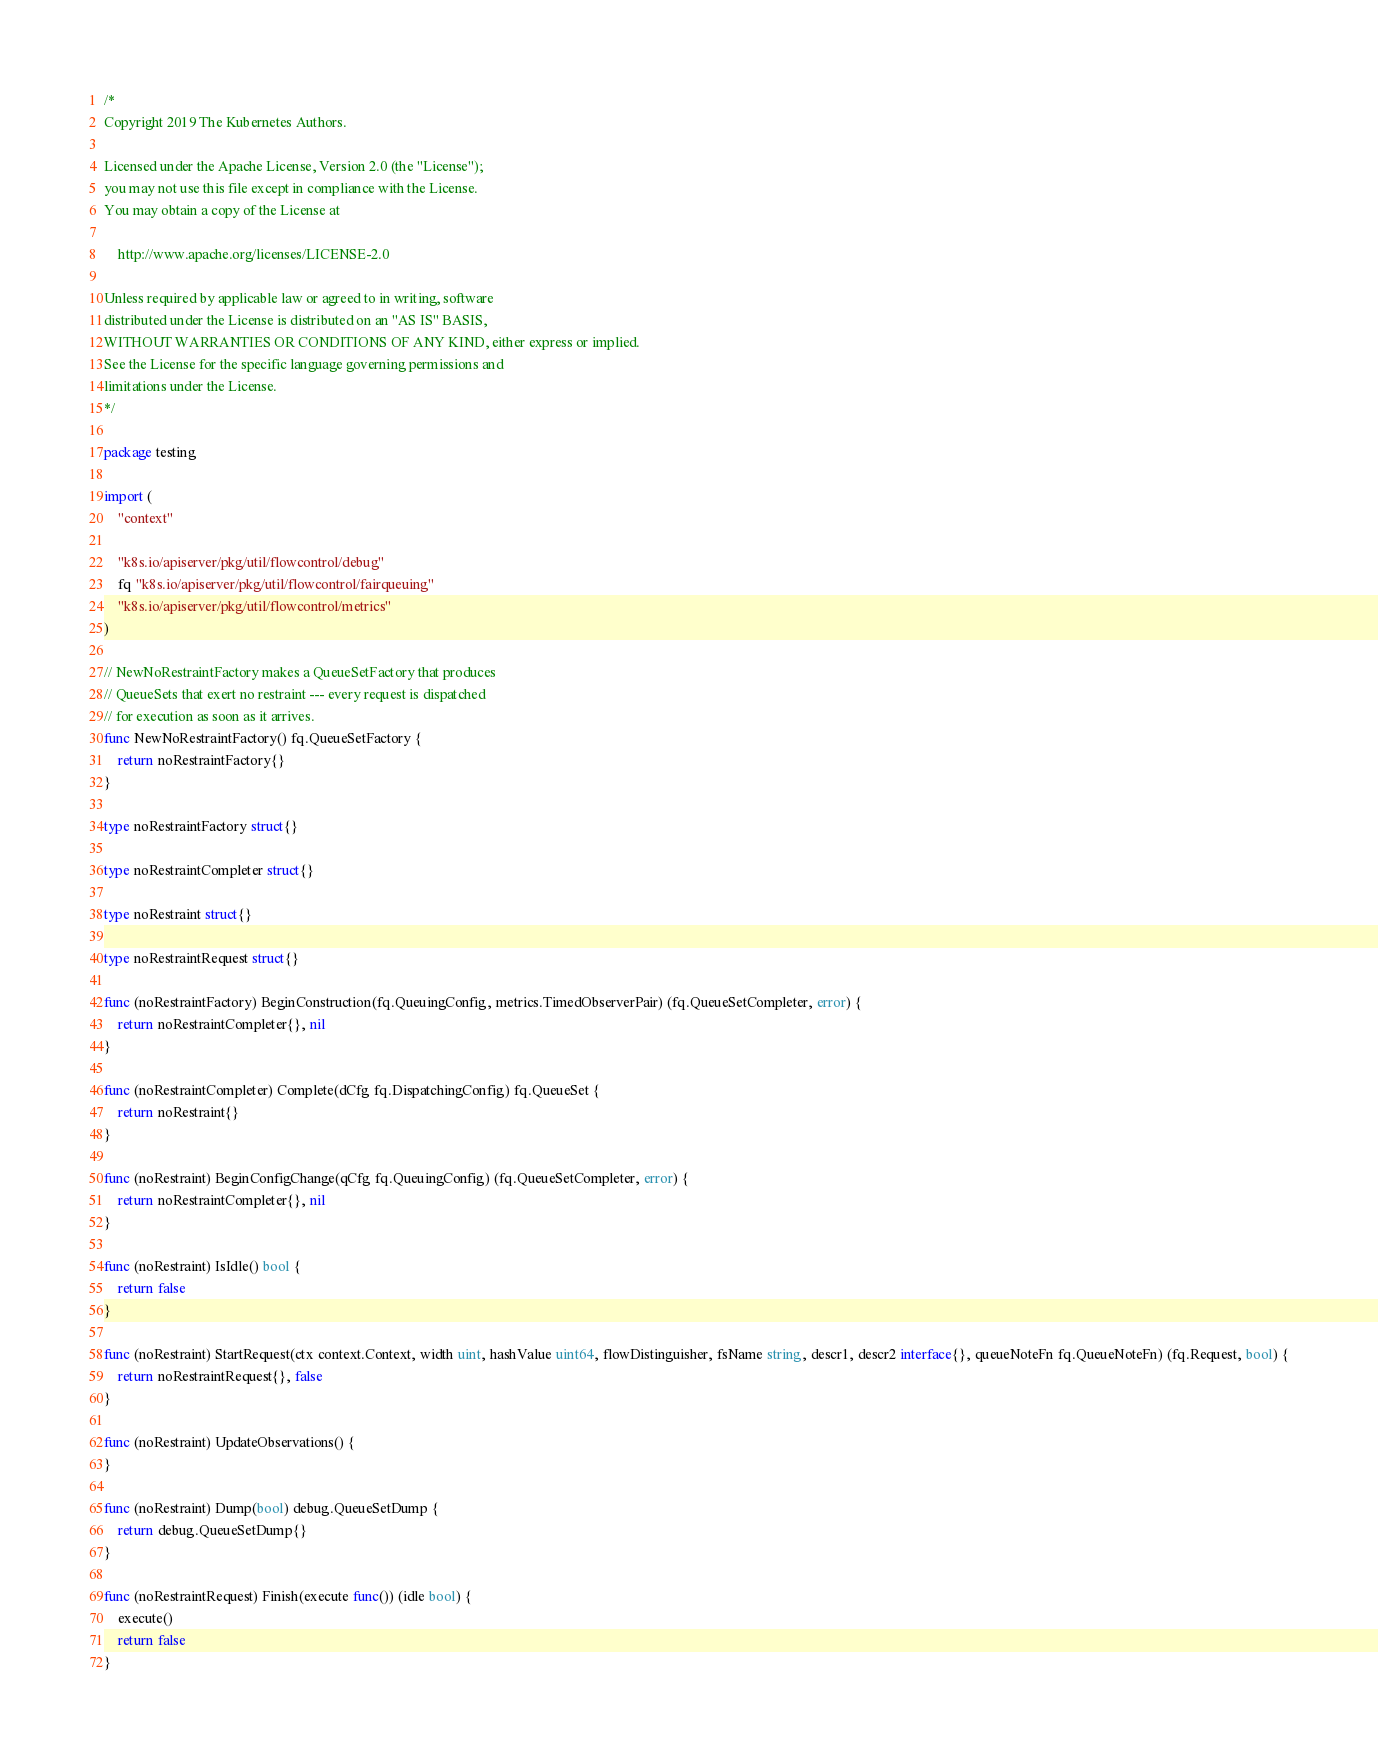<code> <loc_0><loc_0><loc_500><loc_500><_Go_>/*
Copyright 2019 The Kubernetes Authors.

Licensed under the Apache License, Version 2.0 (the "License");
you may not use this file except in compliance with the License.
You may obtain a copy of the License at

    http://www.apache.org/licenses/LICENSE-2.0

Unless required by applicable law or agreed to in writing, software
distributed under the License is distributed on an "AS IS" BASIS,
WITHOUT WARRANTIES OR CONDITIONS OF ANY KIND, either express or implied.
See the License for the specific language governing permissions and
limitations under the License.
*/

package testing

import (
	"context"

	"k8s.io/apiserver/pkg/util/flowcontrol/debug"
	fq "k8s.io/apiserver/pkg/util/flowcontrol/fairqueuing"
	"k8s.io/apiserver/pkg/util/flowcontrol/metrics"
)

// NewNoRestraintFactory makes a QueueSetFactory that produces
// QueueSets that exert no restraint --- every request is dispatched
// for execution as soon as it arrives.
func NewNoRestraintFactory() fq.QueueSetFactory {
	return noRestraintFactory{}
}

type noRestraintFactory struct{}

type noRestraintCompleter struct{}

type noRestraint struct{}

type noRestraintRequest struct{}

func (noRestraintFactory) BeginConstruction(fq.QueuingConfig, metrics.TimedObserverPair) (fq.QueueSetCompleter, error) {
	return noRestraintCompleter{}, nil
}

func (noRestraintCompleter) Complete(dCfg fq.DispatchingConfig) fq.QueueSet {
	return noRestraint{}
}

func (noRestraint) BeginConfigChange(qCfg fq.QueuingConfig) (fq.QueueSetCompleter, error) {
	return noRestraintCompleter{}, nil
}

func (noRestraint) IsIdle() bool {
	return false
}

func (noRestraint) StartRequest(ctx context.Context, width uint, hashValue uint64, flowDistinguisher, fsName string, descr1, descr2 interface{}, queueNoteFn fq.QueueNoteFn) (fq.Request, bool) {
	return noRestraintRequest{}, false
}

func (noRestraint) UpdateObservations() {
}

func (noRestraint) Dump(bool) debug.QueueSetDump {
	return debug.QueueSetDump{}
}

func (noRestraintRequest) Finish(execute func()) (idle bool) {
	execute()
	return false
}
</code> 